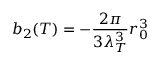<formula> <loc_0><loc_0><loc_500><loc_500>b _ { 2 } ( T ) = - \frac { 2 \pi } { 3 \lambda _ { T } ^ { 3 } } r _ { 0 } ^ { 3 }</formula> 